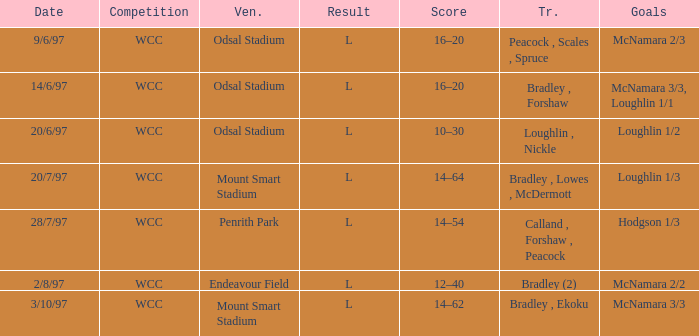What were the goals on 3/10/97? McNamara 3/3. 